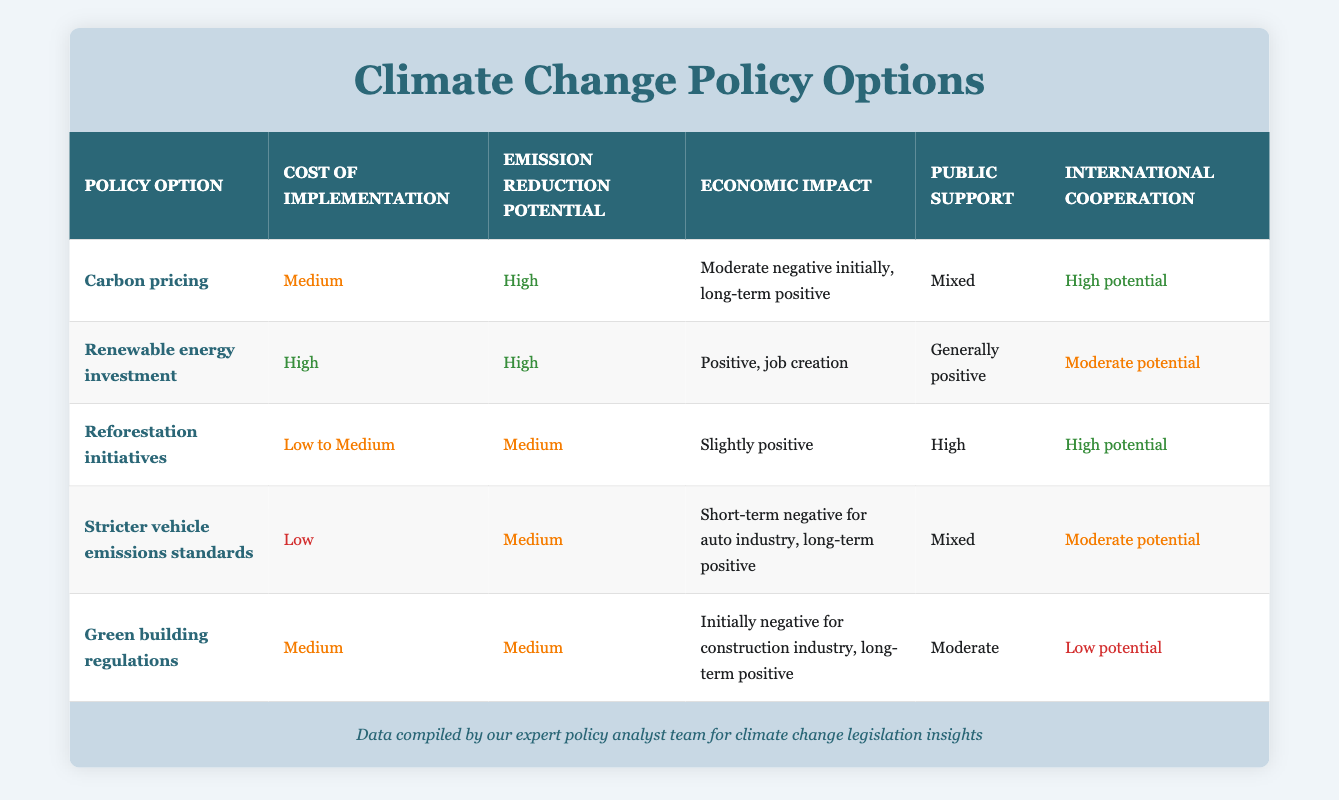What is the cost of implementation for renewable energy investment? The cost of implementation for renewable energy investment can be found directly in the table. It is listed under the "Cost of implementation" column for renewable energy investment as "High."
Answer: High Which policy option has the highest emission reduction potential? By examining the "Emission reduction potential" column for each policy option, both carbon pricing and renewable energy investment are noted to have "High" potential. However, since the question seeks the highest, it can be concluded that those two options top the list.
Answer: Carbon pricing and renewable energy investment How many policy options have a low implementation cost? The table lists the cost of implementation for each policy option. The only option noted as having "Low" cost is "Stricter vehicle emissions standards." Counting this gives a total of one option.
Answer: 1 Is public support generally positive for green building regulations? To determine if public support for green building regulations is generally positive, we look at the "Public support" column for that option, which states "Moderate." Since "Moderate" isn’t classified as generally positive, the answer is no.
Answer: No Which options have high international cooperation potential, and how does their emission reduction potential compare? The table indicates "High potential" for international cooperation in both carbon pricing and reforestation initiatives. Carbon pricing has "High" emission reduction potential, while reforestation initiatives have "Medium." Thus, carbon pricing shows stronger potential for both cooperation and emission reduction.
Answer: Carbon pricing (High) and reforestation initiatives (Medium) What is the economic impact of reforestation initiatives? Looking at the "Economic impact" column for reforestation initiatives, the entry states "Slightly positive." This provides a direct answer pertaining to the economic implications of the initiative.
Answer: Slightly positive How does the economic impact of stricter vehicle emissions standards differ from green building regulations? The economic impact for stricter vehicle emissions standards is given as "Short-term negative for auto industry, long-term positive," while for green building regulations it states "Initially negative for construction industry, long-term positive." Both have short-term negatives but should yield long-term benefits.
Answer: They both have short-term negatives but long-term positives If we consider the three policy options with the highest public support, what would they be? Analyzing the "Public support" column, "Reforestation initiatives" has "High," "Renewable energy investment" is generally positive, while carbon pricing, stricter vehicle emissions standards, and green building regulations are classified as mixed, moderate, and cannot exceed generally positive. Thus, the top three are clear.
Answer: Reforestation initiatives, renewable energy investment, and green building regulations 